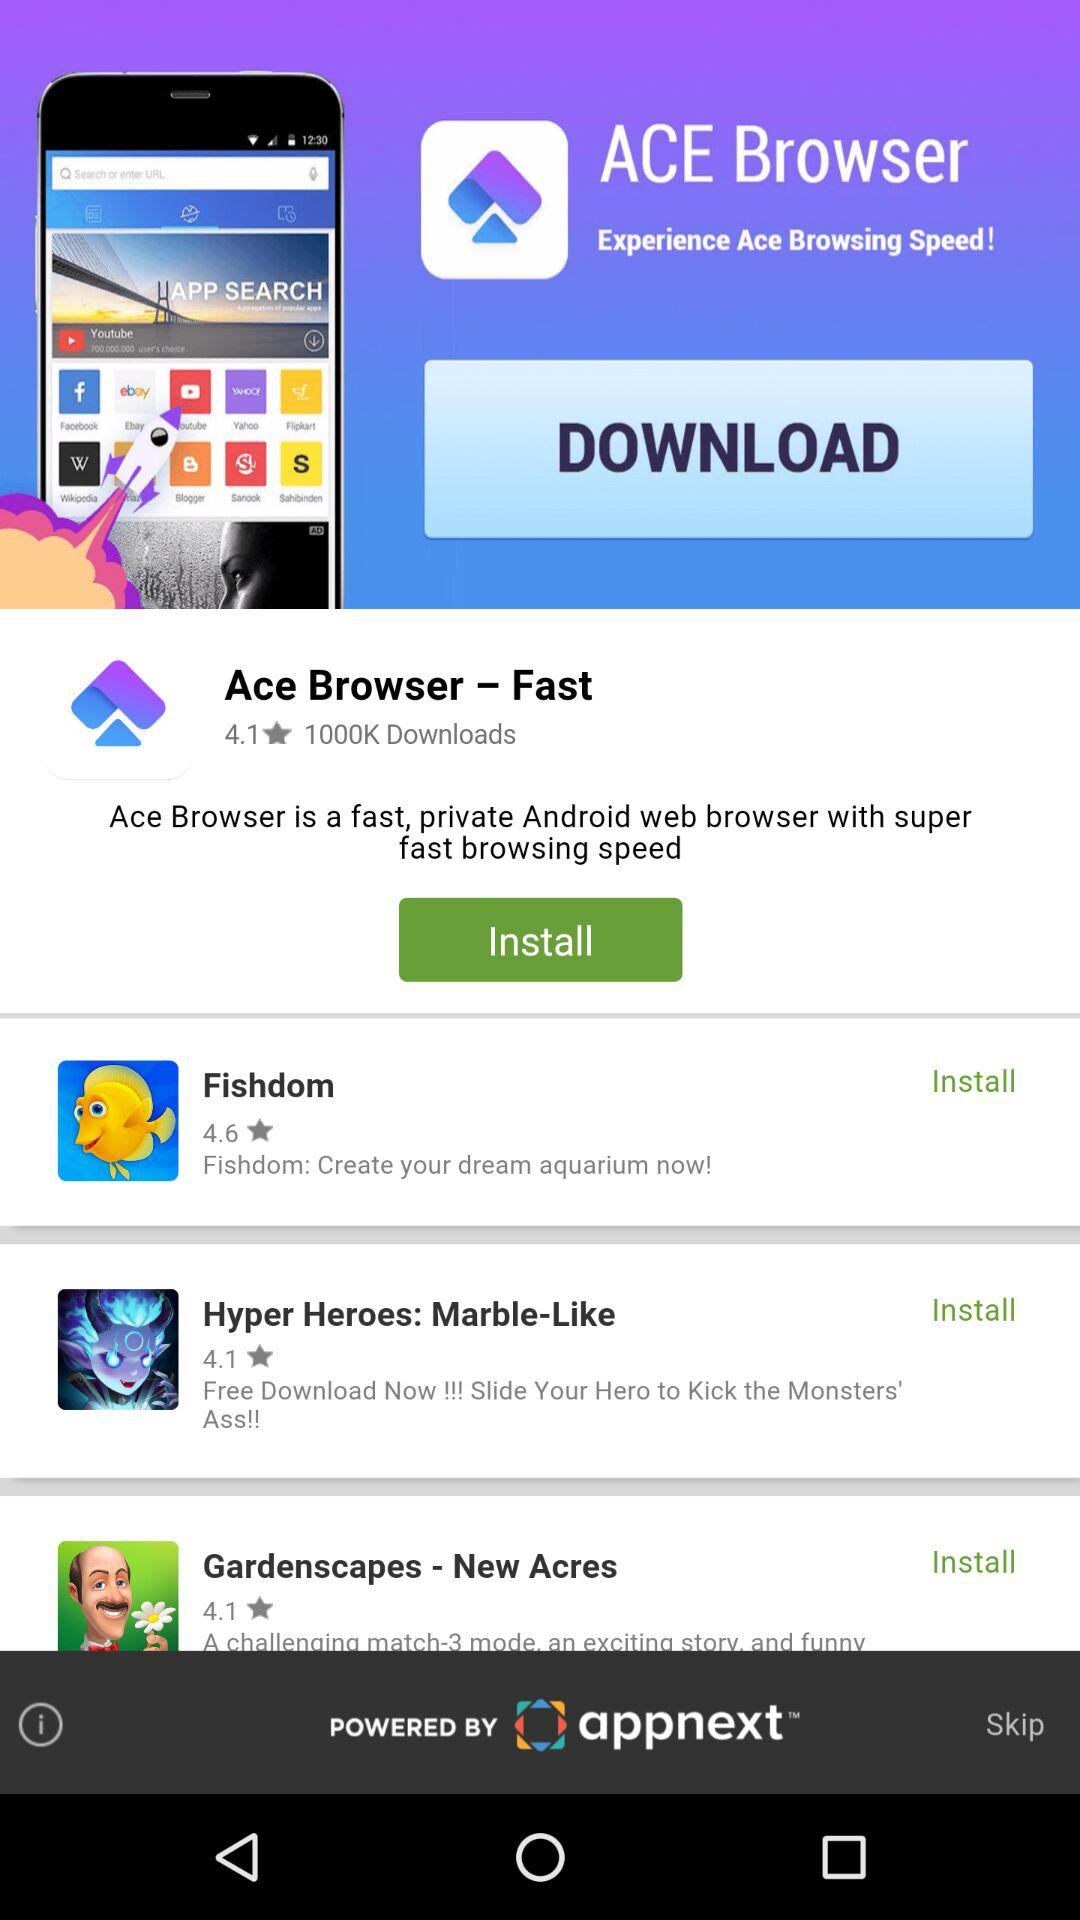How many stars did "Fishdom" get? It got 4.6 stars. 